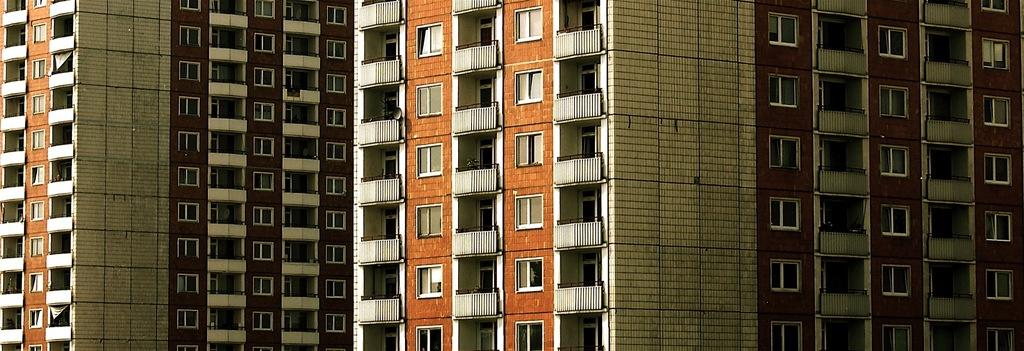What type of structures are present in the image? There are buildings in the image. What features can be observed on the buildings? The buildings have windows and railings. What type of tin can be seen in the mouth of the building in the image? There is no tin present in the image, nor is there any indication of a mouth on the buildings. 